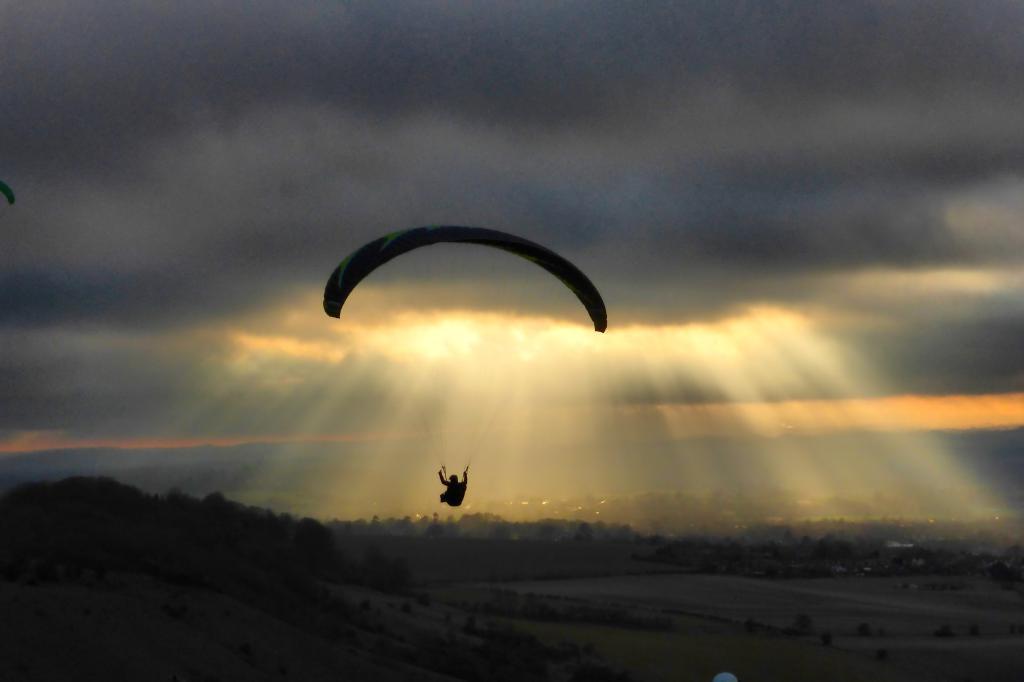Can you describe this image briefly? In this image I can see a person visible on parachute and flying in the air and I can see a sun set in the sky in the middle and I can see trees in the middle 